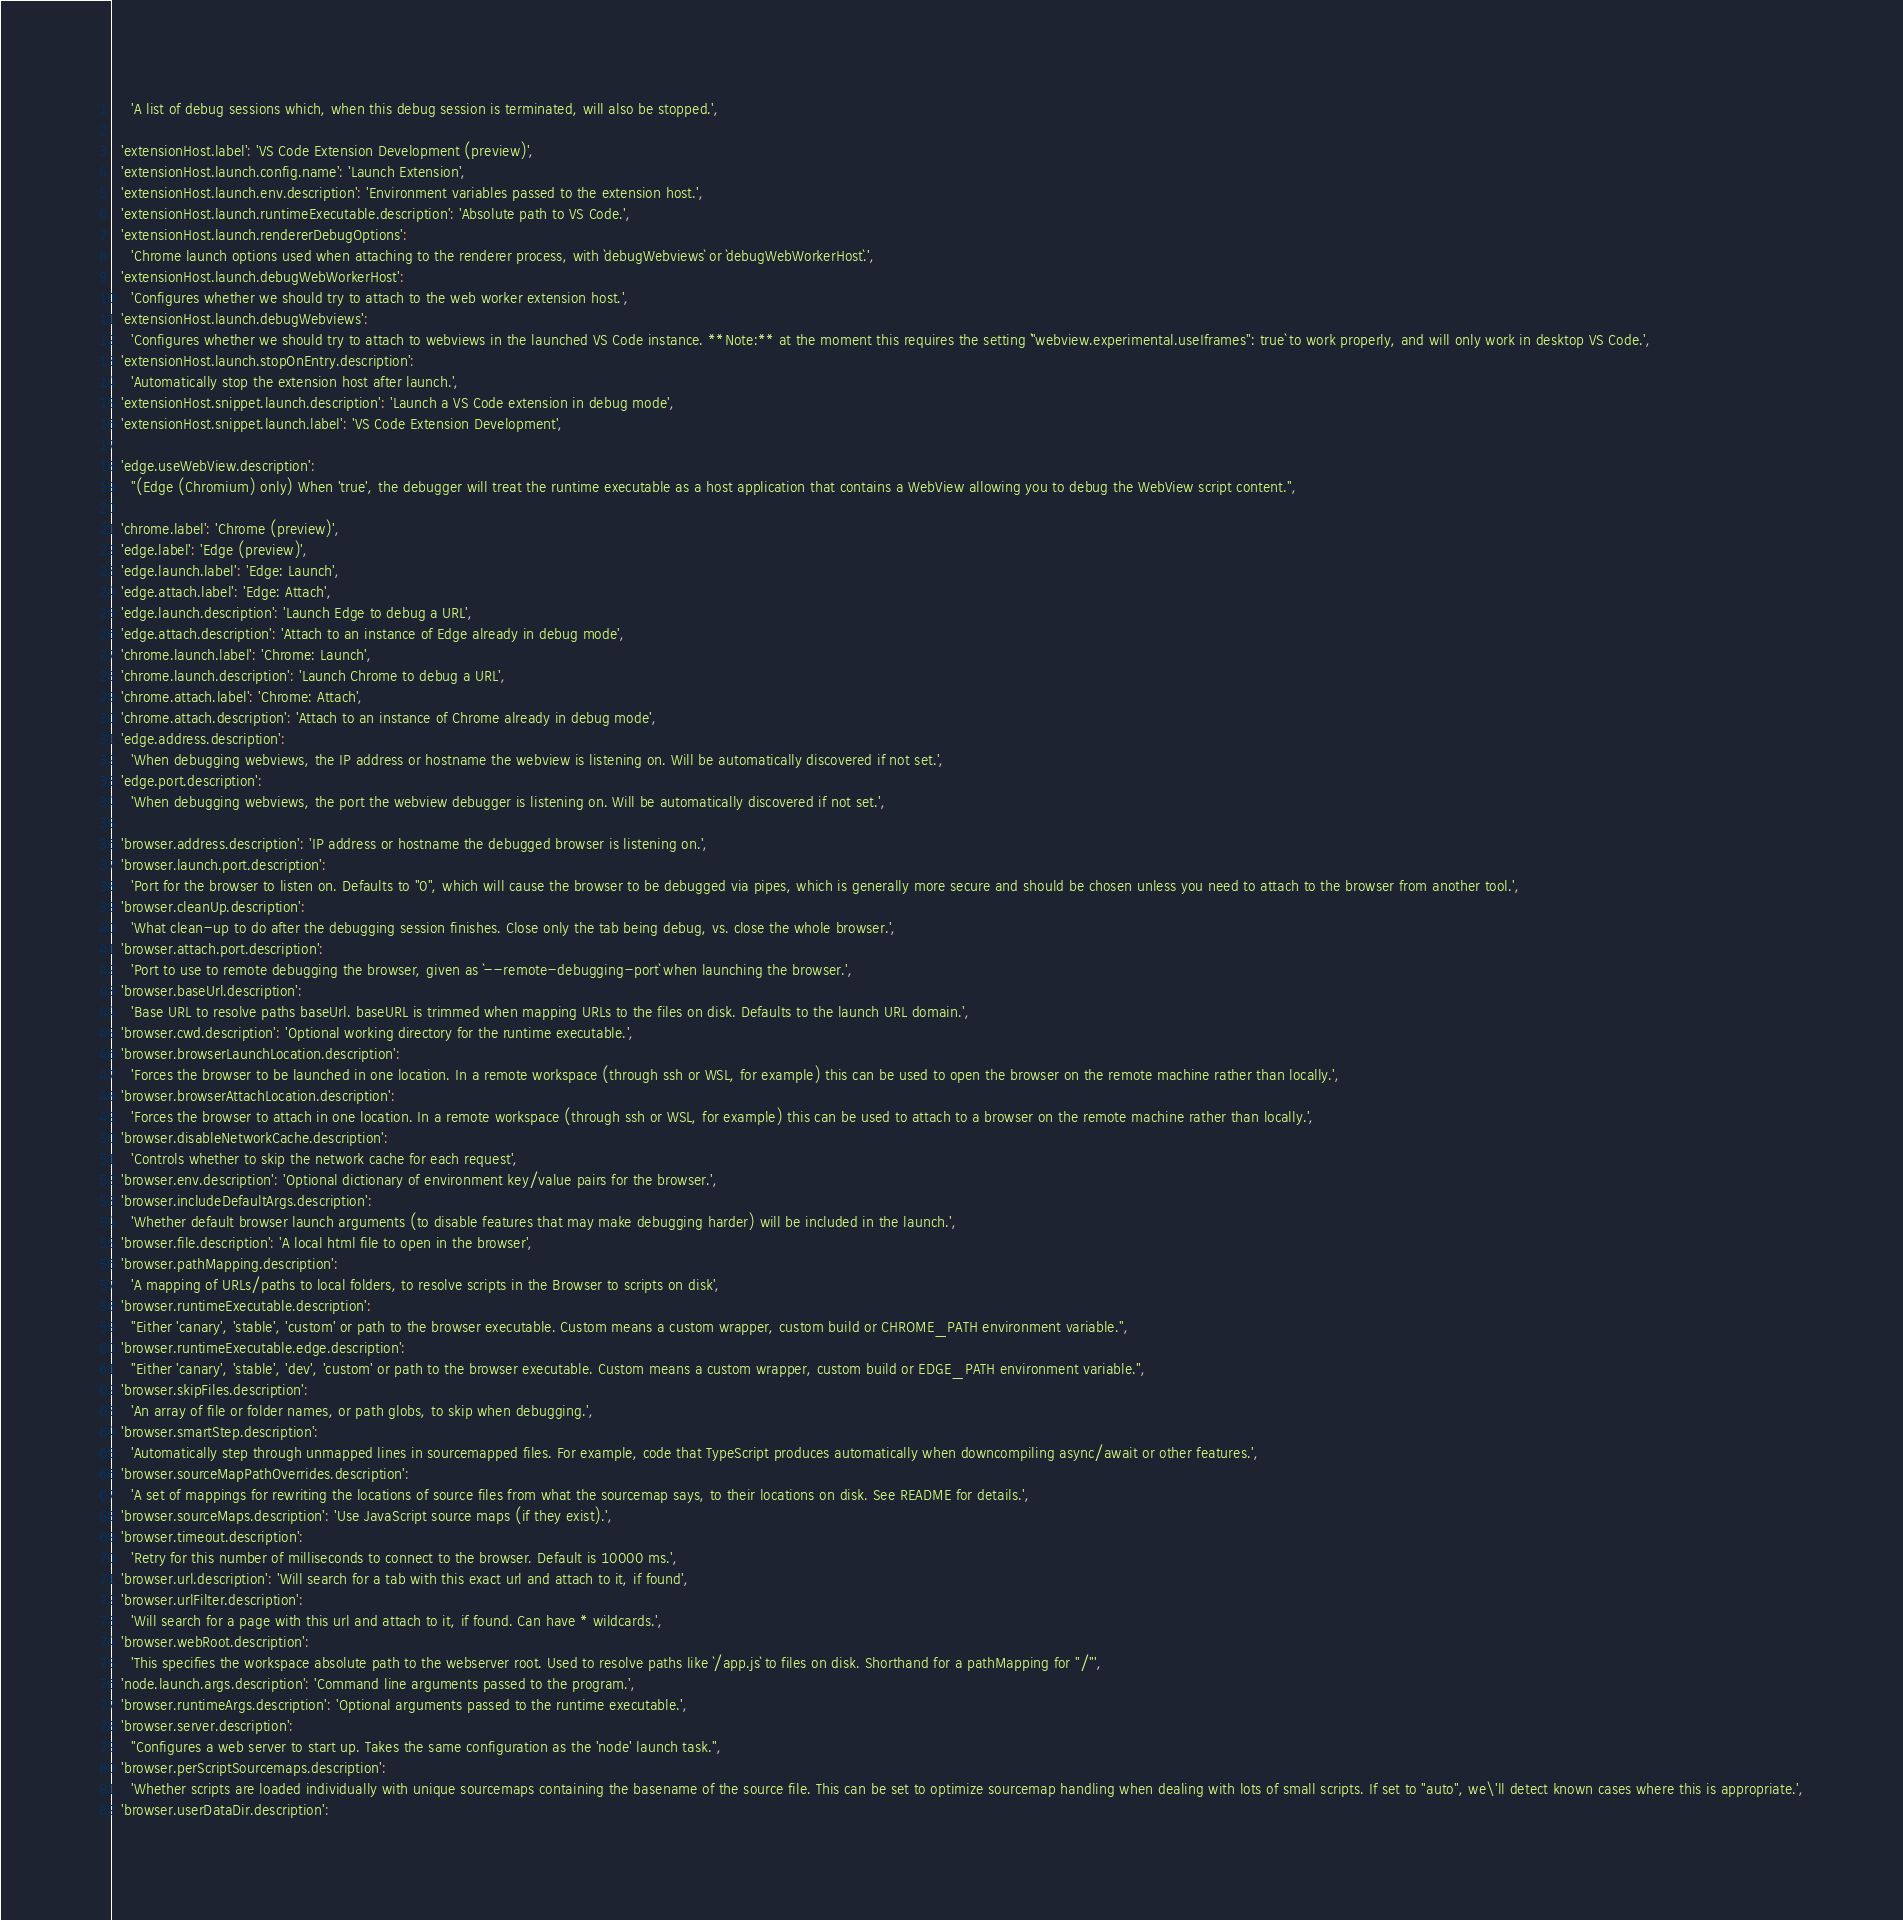<code> <loc_0><loc_0><loc_500><loc_500><_TypeScript_>    'A list of debug sessions which, when this debug session is terminated, will also be stopped.',

  'extensionHost.label': 'VS Code Extension Development (preview)',
  'extensionHost.launch.config.name': 'Launch Extension',
  'extensionHost.launch.env.description': 'Environment variables passed to the extension host.',
  'extensionHost.launch.runtimeExecutable.description': 'Absolute path to VS Code.',
  'extensionHost.launch.rendererDebugOptions':
    'Chrome launch options used when attaching to the renderer process, with `debugWebviews` or `debugWebWorkerHost`.',
  'extensionHost.launch.debugWebWorkerHost':
    'Configures whether we should try to attach to the web worker extension host.',
  'extensionHost.launch.debugWebviews':
    'Configures whether we should try to attach to webviews in the launched VS Code instance. **Note:** at the moment this requires the setting `"webview.experimental.useIframes": true` to work properly, and will only work in desktop VS Code.',
  'extensionHost.launch.stopOnEntry.description':
    'Automatically stop the extension host after launch.',
  'extensionHost.snippet.launch.description': 'Launch a VS Code extension in debug mode',
  'extensionHost.snippet.launch.label': 'VS Code Extension Development',

  'edge.useWebView.description':
    "(Edge (Chromium) only) When 'true', the debugger will treat the runtime executable as a host application that contains a WebView allowing you to debug the WebView script content.",

  'chrome.label': 'Chrome (preview)',
  'edge.label': 'Edge (preview)',
  'edge.launch.label': 'Edge: Launch',
  'edge.attach.label': 'Edge: Attach',
  'edge.launch.description': 'Launch Edge to debug a URL',
  'edge.attach.description': 'Attach to an instance of Edge already in debug mode',
  'chrome.launch.label': 'Chrome: Launch',
  'chrome.launch.description': 'Launch Chrome to debug a URL',
  'chrome.attach.label': 'Chrome: Attach',
  'chrome.attach.description': 'Attach to an instance of Chrome already in debug mode',
  'edge.address.description':
    'When debugging webviews, the IP address or hostname the webview is listening on. Will be automatically discovered if not set.',
  'edge.port.description':
    'When debugging webviews, the port the webview debugger is listening on. Will be automatically discovered if not set.',

  'browser.address.description': 'IP address or hostname the debugged browser is listening on.',
  'browser.launch.port.description':
    'Port for the browser to listen on. Defaults to "0", which will cause the browser to be debugged via pipes, which is generally more secure and should be chosen unless you need to attach to the browser from another tool.',
  'browser.cleanUp.description':
    'What clean-up to do after the debugging session finishes. Close only the tab being debug, vs. close the whole browser.',
  'browser.attach.port.description':
    'Port to use to remote debugging the browser, given as `--remote-debugging-port` when launching the browser.',
  'browser.baseUrl.description':
    'Base URL to resolve paths baseUrl. baseURL is trimmed when mapping URLs to the files on disk. Defaults to the launch URL domain.',
  'browser.cwd.description': 'Optional working directory for the runtime executable.',
  'browser.browserLaunchLocation.description':
    'Forces the browser to be launched in one location. In a remote workspace (through ssh or WSL, for example) this can be used to open the browser on the remote machine rather than locally.',
  'browser.browserAttachLocation.description':
    'Forces the browser to attach in one location. In a remote workspace (through ssh or WSL, for example) this can be used to attach to a browser on the remote machine rather than locally.',
  'browser.disableNetworkCache.description':
    'Controls whether to skip the network cache for each request',
  'browser.env.description': 'Optional dictionary of environment key/value pairs for the browser.',
  'browser.includeDefaultArgs.description':
    'Whether default browser launch arguments (to disable features that may make debugging harder) will be included in the launch.',
  'browser.file.description': 'A local html file to open in the browser',
  'browser.pathMapping.description':
    'A mapping of URLs/paths to local folders, to resolve scripts in the Browser to scripts on disk',
  'browser.runtimeExecutable.description':
    "Either 'canary', 'stable', 'custom' or path to the browser executable. Custom means a custom wrapper, custom build or CHROME_PATH environment variable.",
  'browser.runtimeExecutable.edge.description':
    "Either 'canary', 'stable', 'dev', 'custom' or path to the browser executable. Custom means a custom wrapper, custom build or EDGE_PATH environment variable.",
  'browser.skipFiles.description':
    'An array of file or folder names, or path globs, to skip when debugging.',
  'browser.smartStep.description':
    'Automatically step through unmapped lines in sourcemapped files. For example, code that TypeScript produces automatically when downcompiling async/await or other features.',
  'browser.sourceMapPathOverrides.description':
    'A set of mappings for rewriting the locations of source files from what the sourcemap says, to their locations on disk. See README for details.',
  'browser.sourceMaps.description': 'Use JavaScript source maps (if they exist).',
  'browser.timeout.description':
    'Retry for this number of milliseconds to connect to the browser. Default is 10000 ms.',
  'browser.url.description': 'Will search for a tab with this exact url and attach to it, if found',
  'browser.urlFilter.description':
    'Will search for a page with this url and attach to it, if found. Can have * wildcards.',
  'browser.webRoot.description':
    'This specifies the workspace absolute path to the webserver root. Used to resolve paths like `/app.js` to files on disk. Shorthand for a pathMapping for "/"',
  'node.launch.args.description': 'Command line arguments passed to the program.',
  'browser.runtimeArgs.description': 'Optional arguments passed to the runtime executable.',
  'browser.server.description':
    "Configures a web server to start up. Takes the same configuration as the 'node' launch task.",
  'browser.perScriptSourcemaps.description':
    'Whether scripts are loaded individually with unique sourcemaps containing the basename of the source file. This can be set to optimize sourcemap handling when dealing with lots of small scripts. If set to "auto", we\'ll detect known cases where this is appropriate.',
  'browser.userDataDir.description':</code> 